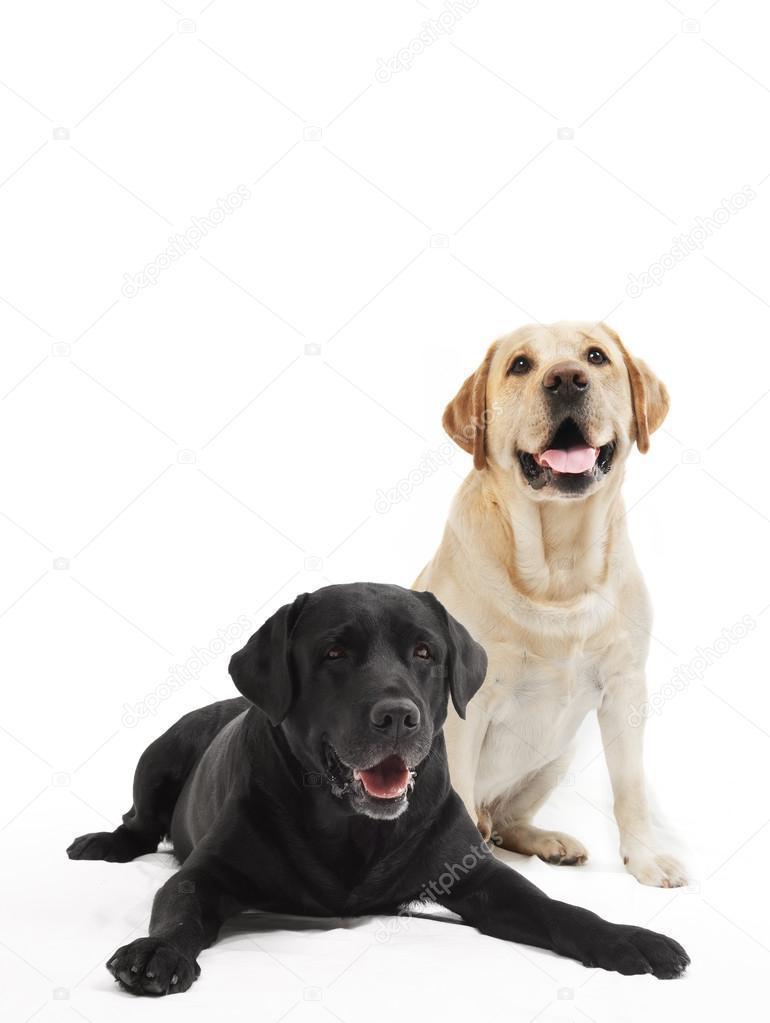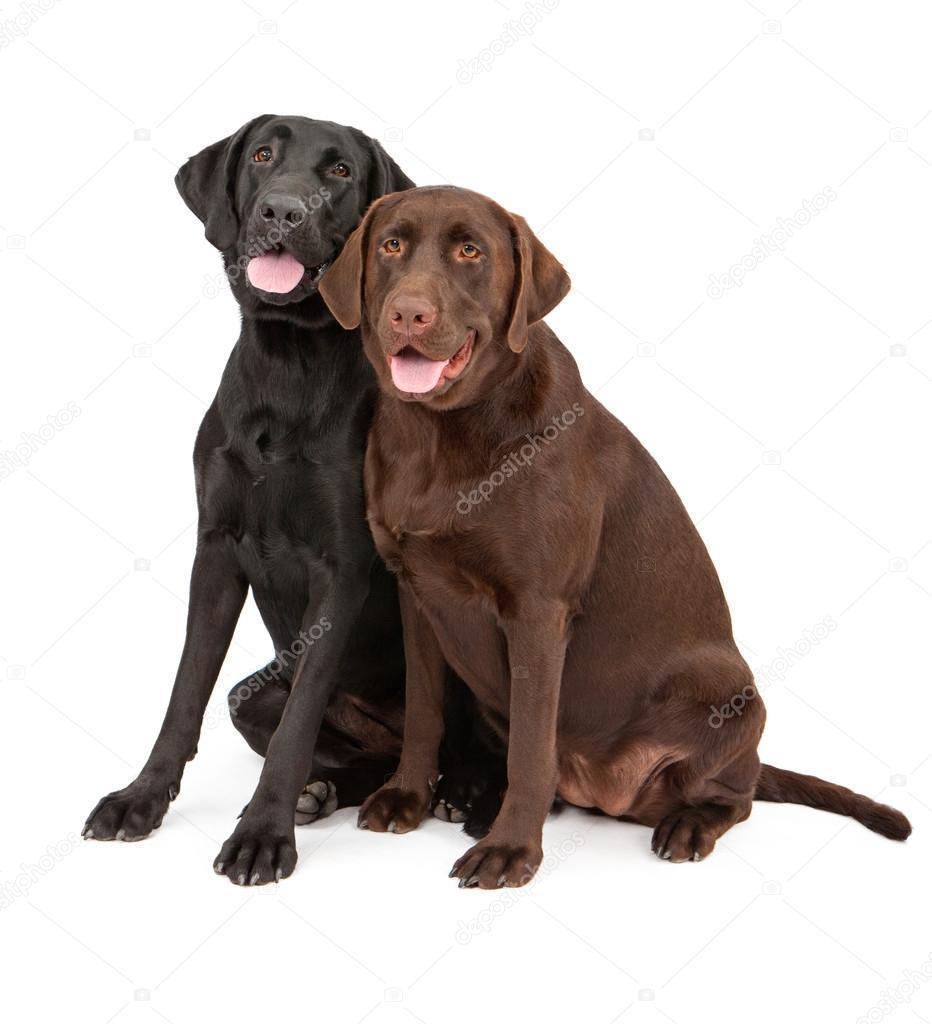The first image is the image on the left, the second image is the image on the right. For the images displayed, is the sentence "none of the dogs in the image pair have collars on" factually correct? Answer yes or no. Yes. The first image is the image on the left, the second image is the image on the right. Analyze the images presented: Is the assertion "Two dogs are sitting and two dogs are lying down." valid? Answer yes or no. No. 